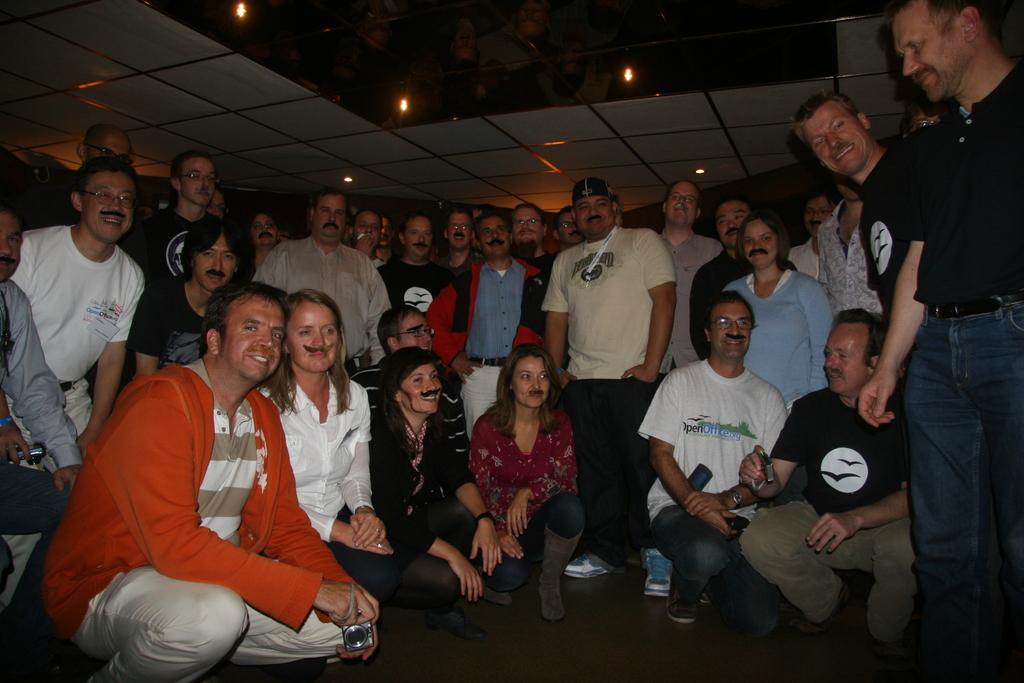Could you give a brief overview of what you see in this image? In this image I can see number of persons are standing and few persons are sitting on the floor and I can see a person wearing orange colored jacket is holding a camera in his hand. In the background I can see the ceiling and few lights. 